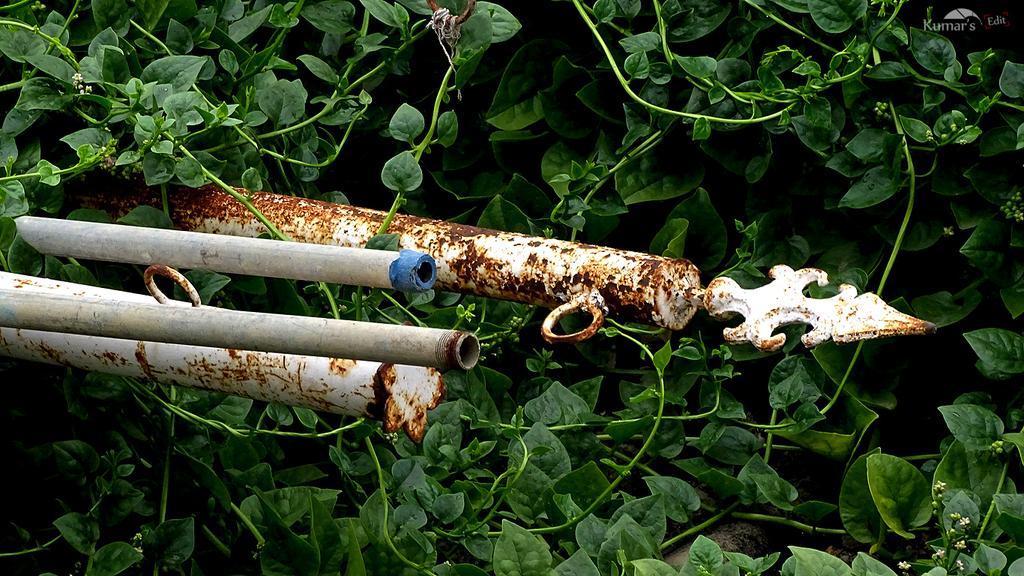Please provide a concise description of this image. In the center of the image there is a rod. In the background of the image there are plants. 